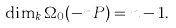<formula> <loc_0><loc_0><loc_500><loc_500>\dim _ { k } \Omega _ { 0 } ( - n P ) = n - 1 .</formula> 